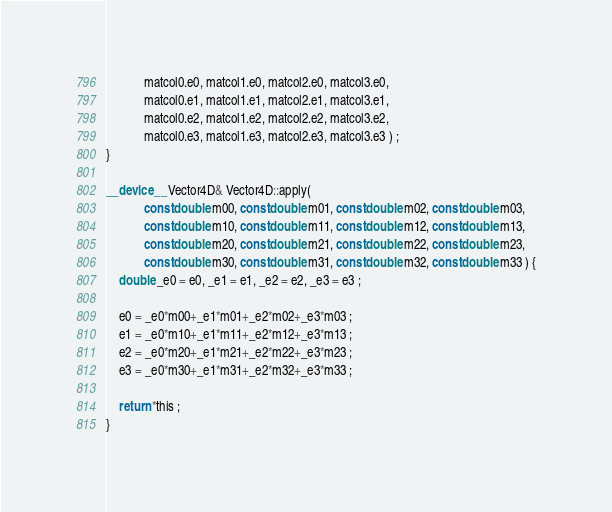Convert code to text. <code><loc_0><loc_0><loc_500><loc_500><_Cuda_>			matcol0.e0, matcol1.e0, matcol2.e0, matcol3.e0,
			matcol0.e1, matcol1.e1, matcol2.e1, matcol3.e1,
			matcol0.e2, matcol1.e2, matcol2.e2, matcol3.e2,
			matcol0.e3, matcol1.e3, matcol2.e3, matcol3.e3 ) ;
}

__device__ Vector4D& Vector4D::apply(
			const double m00, const double m01, const double m02, const double m03,
			const double m10, const double m11, const double m12, const double m13,
			const double m20, const double m21, const double m22, const double m23,
			const double m30, const double m31, const double m32, const double m33 ) {
	double _e0 = e0, _e1 = e1, _e2 = e2, _e3 = e3 ;

	e0 = _e0*m00+_e1*m01+_e2*m02+_e3*m03 ;
	e1 = _e0*m10+_e1*m11+_e2*m12+_e3*m13 ;
	e2 = _e0*m20+_e1*m21+_e2*m22+_e3*m23 ;
	e3 = _e0*m30+_e1*m31+_e2*m32+_e3*m33 ;

	return *this ;
}
</code> 